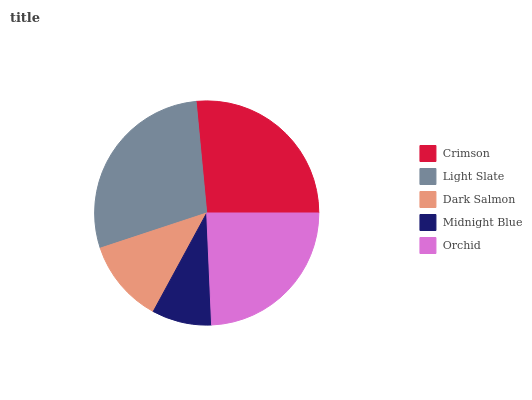Is Midnight Blue the minimum?
Answer yes or no. Yes. Is Light Slate the maximum?
Answer yes or no. Yes. Is Dark Salmon the minimum?
Answer yes or no. No. Is Dark Salmon the maximum?
Answer yes or no. No. Is Light Slate greater than Dark Salmon?
Answer yes or no. Yes. Is Dark Salmon less than Light Slate?
Answer yes or no. Yes. Is Dark Salmon greater than Light Slate?
Answer yes or no. No. Is Light Slate less than Dark Salmon?
Answer yes or no. No. Is Orchid the high median?
Answer yes or no. Yes. Is Orchid the low median?
Answer yes or no. Yes. Is Midnight Blue the high median?
Answer yes or no. No. Is Midnight Blue the low median?
Answer yes or no. No. 